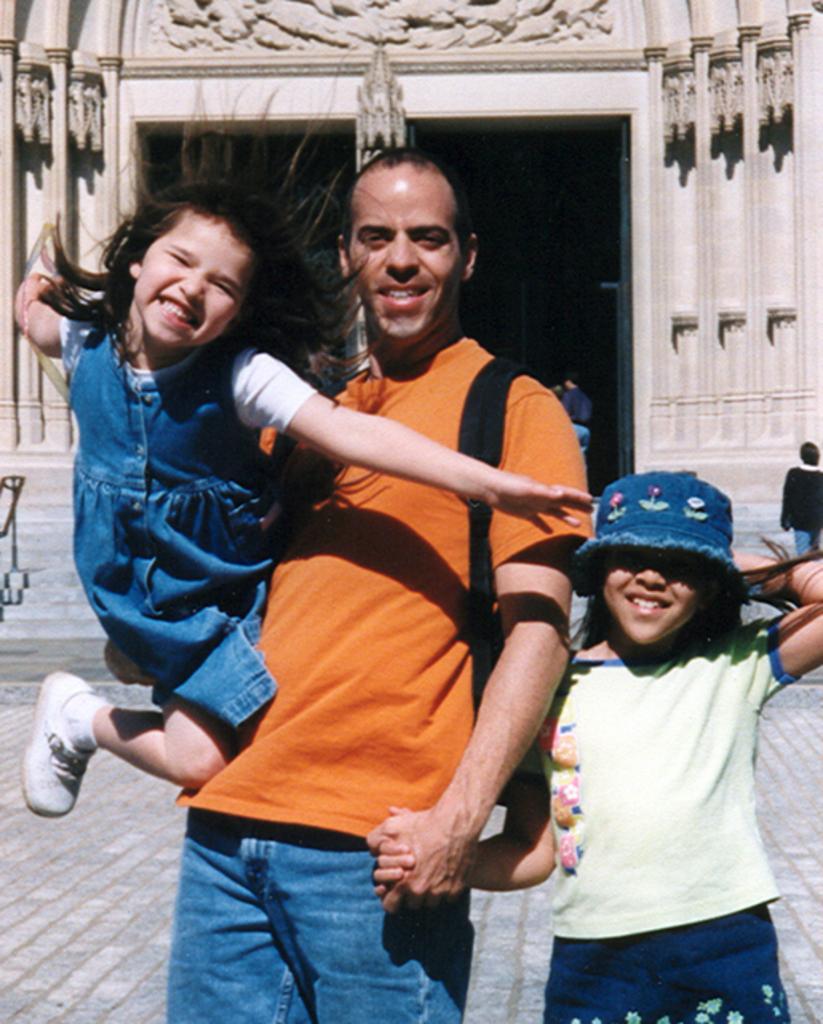Describe this image in one or two sentences. In this image we can see a man is standing and carrying a bag on his shoulders and holding kids with his hands. In the background we can see designs on the walls, few persons and objects. 